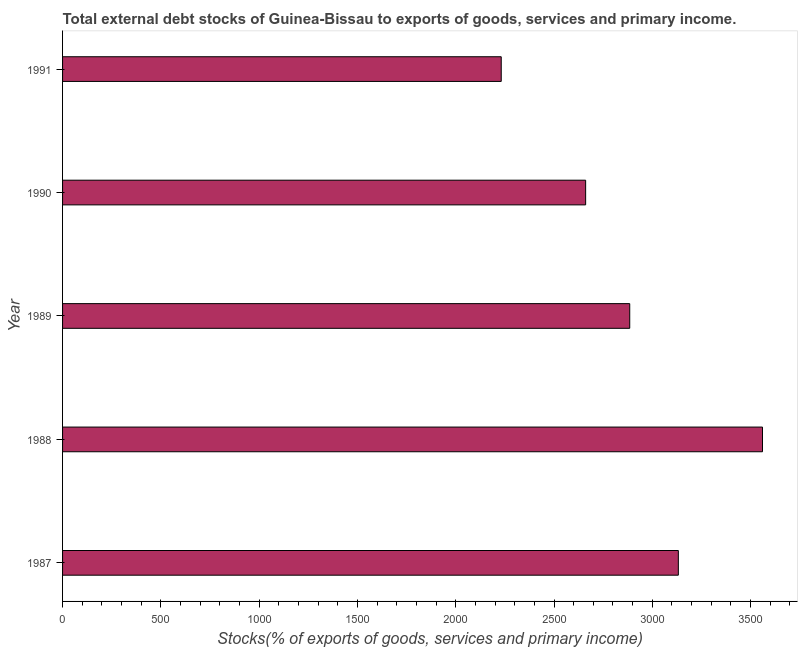What is the title of the graph?
Make the answer very short. Total external debt stocks of Guinea-Bissau to exports of goods, services and primary income. What is the label or title of the X-axis?
Keep it short and to the point. Stocks(% of exports of goods, services and primary income). What is the external debt stocks in 1991?
Give a very brief answer. 2231.5. Across all years, what is the maximum external debt stocks?
Offer a terse response. 3560.54. Across all years, what is the minimum external debt stocks?
Your answer should be compact. 2231.5. What is the sum of the external debt stocks?
Offer a very short reply. 1.45e+04. What is the difference between the external debt stocks in 1987 and 1990?
Provide a succinct answer. 471.54. What is the average external debt stocks per year?
Your response must be concise. 2894.12. What is the median external debt stocks?
Ensure brevity in your answer.  2885.18. In how many years, is the external debt stocks greater than 2800 %?
Offer a very short reply. 3. What is the ratio of the external debt stocks in 1989 to that in 1990?
Make the answer very short. 1.08. Is the external debt stocks in 1988 less than that in 1990?
Provide a short and direct response. No. What is the difference between the highest and the second highest external debt stocks?
Offer a very short reply. 428.09. What is the difference between the highest and the lowest external debt stocks?
Your response must be concise. 1329.05. How many bars are there?
Keep it short and to the point. 5. Are all the bars in the graph horizontal?
Your answer should be very brief. Yes. Are the values on the major ticks of X-axis written in scientific E-notation?
Offer a terse response. No. What is the Stocks(% of exports of goods, services and primary income) of 1987?
Make the answer very short. 3132.45. What is the Stocks(% of exports of goods, services and primary income) of 1988?
Give a very brief answer. 3560.54. What is the Stocks(% of exports of goods, services and primary income) of 1989?
Make the answer very short. 2885.18. What is the Stocks(% of exports of goods, services and primary income) in 1990?
Make the answer very short. 2660.92. What is the Stocks(% of exports of goods, services and primary income) in 1991?
Offer a very short reply. 2231.5. What is the difference between the Stocks(% of exports of goods, services and primary income) in 1987 and 1988?
Ensure brevity in your answer.  -428.09. What is the difference between the Stocks(% of exports of goods, services and primary income) in 1987 and 1989?
Make the answer very short. 247.28. What is the difference between the Stocks(% of exports of goods, services and primary income) in 1987 and 1990?
Ensure brevity in your answer.  471.54. What is the difference between the Stocks(% of exports of goods, services and primary income) in 1987 and 1991?
Give a very brief answer. 900.96. What is the difference between the Stocks(% of exports of goods, services and primary income) in 1988 and 1989?
Your answer should be compact. 675.36. What is the difference between the Stocks(% of exports of goods, services and primary income) in 1988 and 1990?
Offer a very short reply. 899.63. What is the difference between the Stocks(% of exports of goods, services and primary income) in 1988 and 1991?
Provide a short and direct response. 1329.05. What is the difference between the Stocks(% of exports of goods, services and primary income) in 1989 and 1990?
Keep it short and to the point. 224.26. What is the difference between the Stocks(% of exports of goods, services and primary income) in 1989 and 1991?
Your response must be concise. 653.68. What is the difference between the Stocks(% of exports of goods, services and primary income) in 1990 and 1991?
Give a very brief answer. 429.42. What is the ratio of the Stocks(% of exports of goods, services and primary income) in 1987 to that in 1989?
Provide a succinct answer. 1.09. What is the ratio of the Stocks(% of exports of goods, services and primary income) in 1987 to that in 1990?
Make the answer very short. 1.18. What is the ratio of the Stocks(% of exports of goods, services and primary income) in 1987 to that in 1991?
Give a very brief answer. 1.4. What is the ratio of the Stocks(% of exports of goods, services and primary income) in 1988 to that in 1989?
Provide a short and direct response. 1.23. What is the ratio of the Stocks(% of exports of goods, services and primary income) in 1988 to that in 1990?
Offer a terse response. 1.34. What is the ratio of the Stocks(% of exports of goods, services and primary income) in 1988 to that in 1991?
Provide a succinct answer. 1.6. What is the ratio of the Stocks(% of exports of goods, services and primary income) in 1989 to that in 1990?
Your response must be concise. 1.08. What is the ratio of the Stocks(% of exports of goods, services and primary income) in 1989 to that in 1991?
Ensure brevity in your answer.  1.29. What is the ratio of the Stocks(% of exports of goods, services and primary income) in 1990 to that in 1991?
Offer a very short reply. 1.19. 